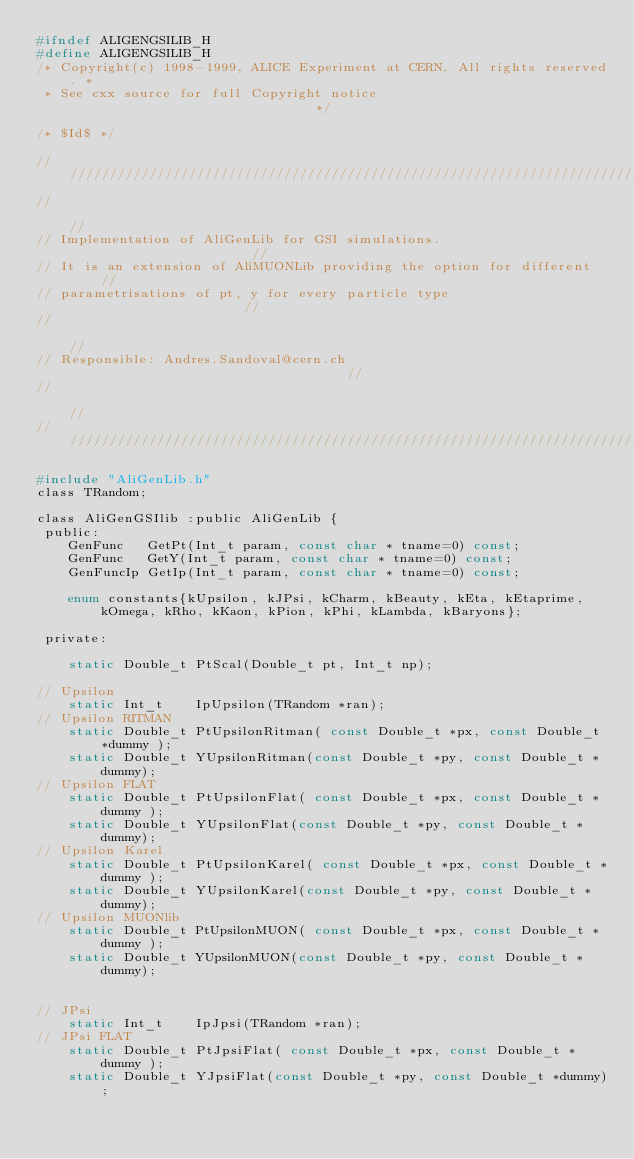Convert code to text. <code><loc_0><loc_0><loc_500><loc_500><_C_>#ifndef ALIGENGSILIB_H
#define ALIGENGSILIB_H
/* Copyright(c) 1998-1999, ALICE Experiment at CERN, All rights reserved. *
 * See cxx source for full Copyright notice                               */

/* $Id$ */

/////////////////////////////////////////////////////////////////////////////
//                                                                         //
// Implementation of AliGenLib for GSI simulations.                        //
// It is an extension of AliMUONLib providing the option for different     //
// parametrisations of pt, y for every particle type                       //
//                                                                         //
// Responsible: Andres.Sandoval@cern.ch                                    //
//                                                                         //
/////////////////////////////////////////////////////////////////////////////

#include "AliGenLib.h"
class TRandom;

class AliGenGSIlib :public AliGenLib {
 public:
    GenFunc   GetPt(Int_t param, const char * tname=0) const;
    GenFunc   GetY(Int_t param, const char * tname=0) const;
    GenFuncIp GetIp(Int_t param, const char * tname=0) const;    

    enum constants{kUpsilon, kJPsi, kCharm, kBeauty, kEta, kEtaprime, kOmega, kRho, kKaon, kPion, kPhi, kLambda, kBaryons};

 private:

    static Double_t PtScal(Double_t pt, Int_t np);

// Upsilon
    static Int_t    IpUpsilon(TRandom *ran);
// Upsilon RITMAN   
    static Double_t PtUpsilonRitman( const Double_t *px, const Double_t *dummy );
    static Double_t YUpsilonRitman(const Double_t *py, const Double_t *dummy);
// Upsilon FLAT   
    static Double_t PtUpsilonFlat( const Double_t *px, const Double_t *dummy );
    static Double_t YUpsilonFlat(const Double_t *py, const Double_t *dummy);
// Upsilon Karel
    static Double_t PtUpsilonKarel( const Double_t *px, const Double_t *dummy );
    static Double_t YUpsilonKarel(const Double_t *py, const Double_t *dummy);
// Upsilon MUONlib
    static Double_t PtUpsilonMUON( const Double_t *px, const Double_t *dummy );
    static Double_t YUpsilonMUON(const Double_t *py, const Double_t *dummy);


// JPsi 
    static Int_t    IpJpsi(TRandom *ran);
// JPsi FLAT   
    static Double_t PtJpsiFlat( const Double_t *px, const Double_t *dummy );
    static Double_t YJpsiFlat(const Double_t *py, const Double_t *dummy);</code> 